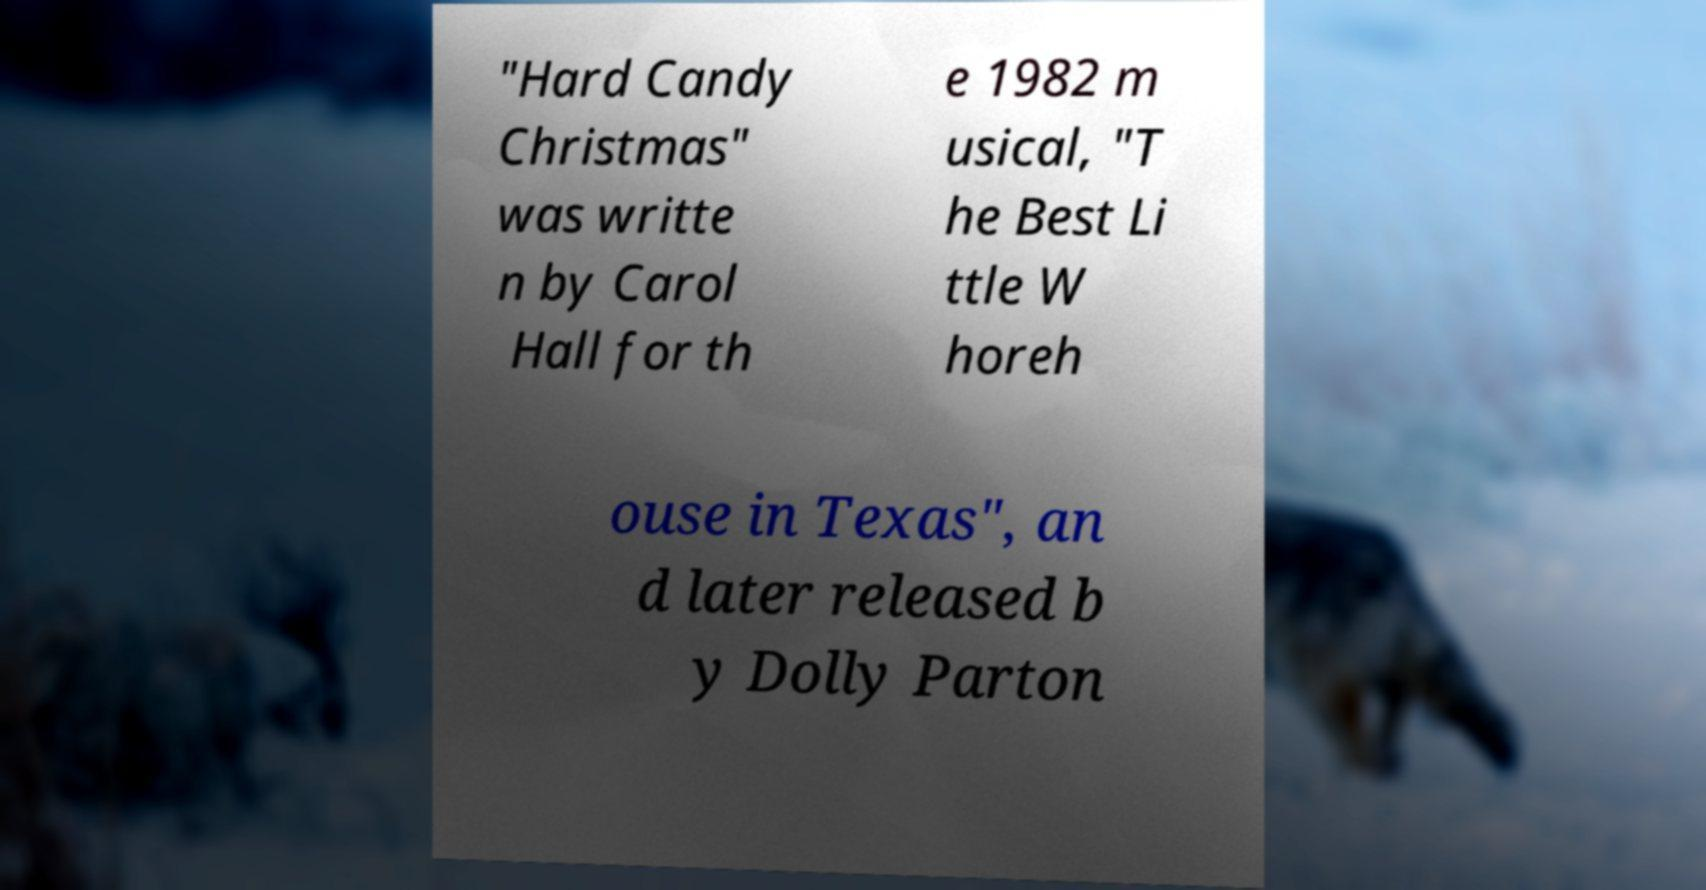I need the written content from this picture converted into text. Can you do that? "Hard Candy Christmas" was writte n by Carol Hall for th e 1982 m usical, "T he Best Li ttle W horeh ouse in Texas", an d later released b y Dolly Parton 